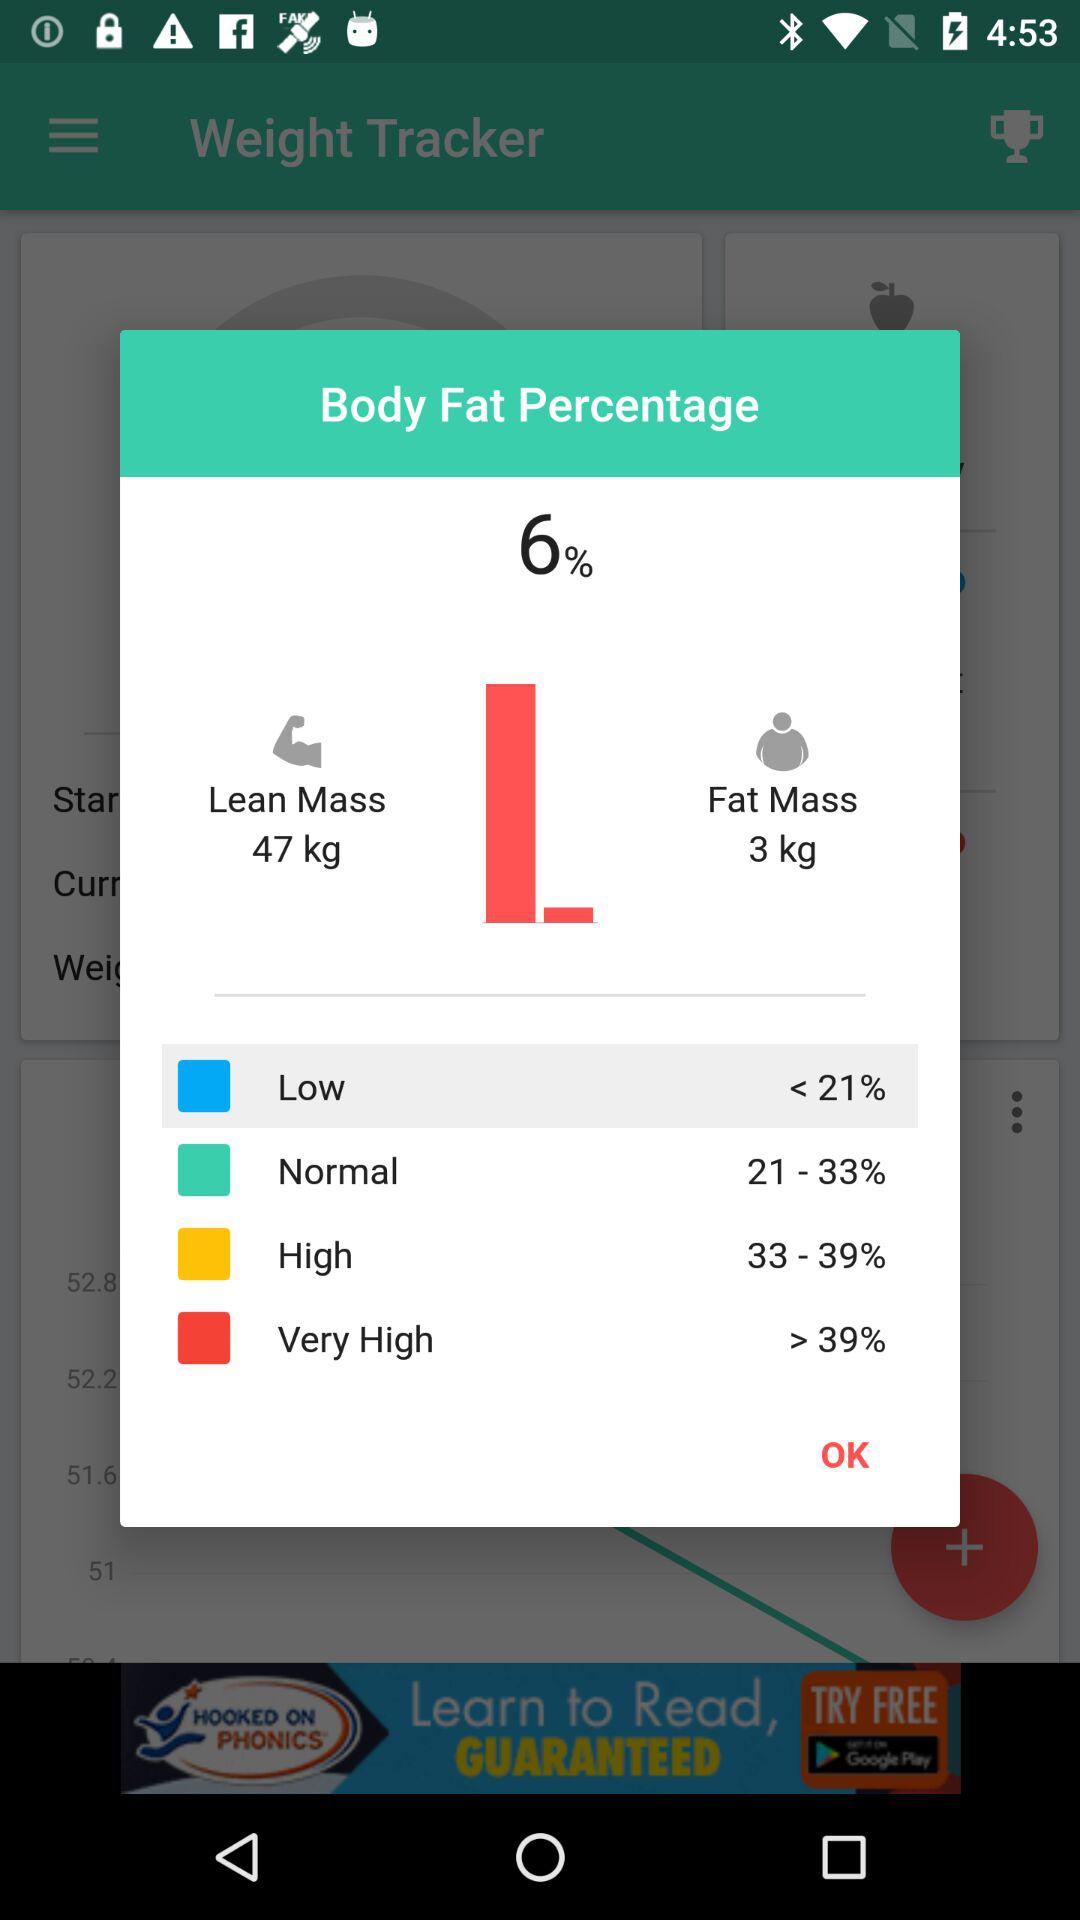What is the body fat percentage calculated from 33-39? The body fat percentage calculated for 33-39 is high. 